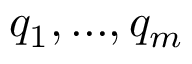<formula> <loc_0><loc_0><loc_500><loc_500>q _ { 1 } , \dots , q _ { m }</formula> 